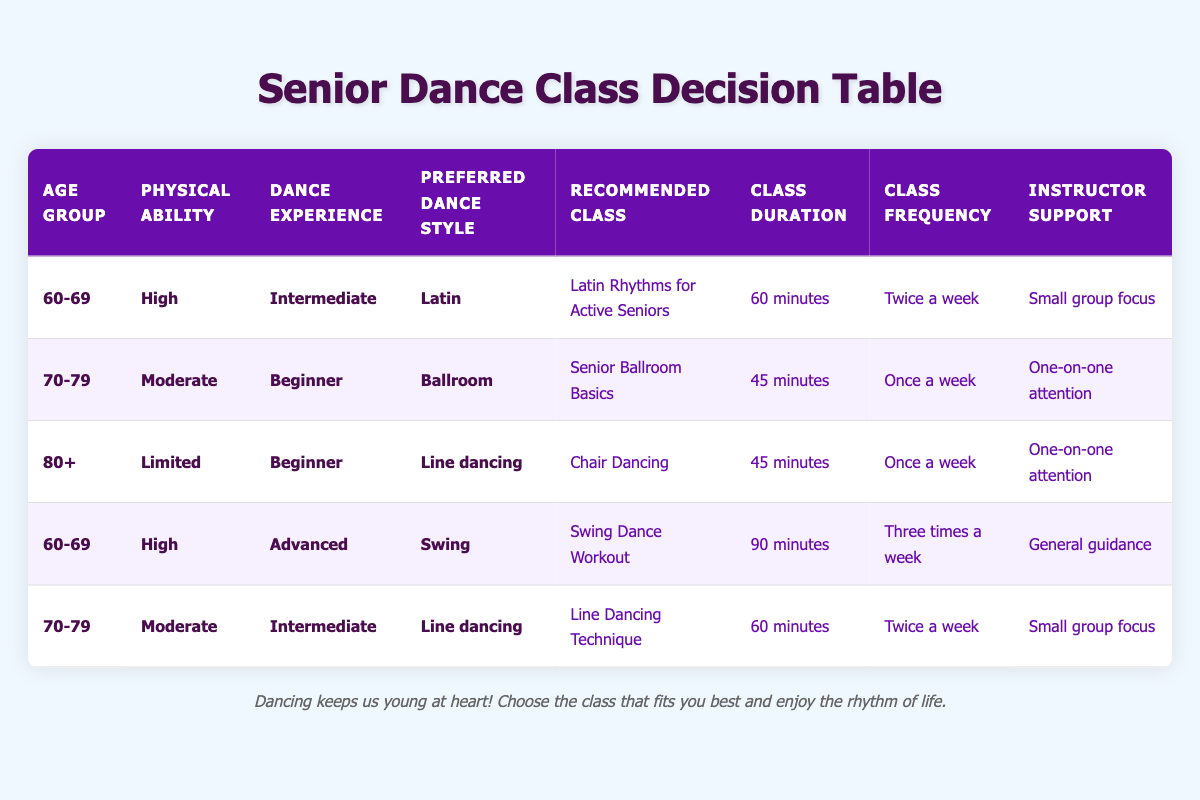What is the recommended class for an 80+ individual with limited physical ability and beginner dance experience in line dancing? The table indicates that for individuals aged 80+ with limited physical ability and beginner dance experience in line dancing, the recommended class is "Chair Dancing."
Answer: Chair Dancing How long is the class duration for "Swing Dance Workout"? The duration of "Swing Dance Workout" is specified in the table as 90 minutes.
Answer: 90 minutes Is "Senior Ballroom Basics" recommended for someone aged 70-79 with beginner dance experience? Yes, the table shows that "Senior Ballroom Basics" is indeed recommended for individuals aged 70-79 who are beginners.
Answer: Yes What class is recommended for someone aged 60-69 with high physical ability and advanced dance experience seeking a swing dance style? According to the table, the recommended class for this profile is "Swing Dance Workout."
Answer: Swing Dance Workout On how many occasions per week is "Line Dancing Technique" offered? The table specifies that "Line Dancing Technique" is offered twice a week.
Answer: Twice a week What is the average class duration for the classes recommended for individuals aged 70-79? To find the average duration: the classes for this age group are "Senior Ballroom Basics" (45 minutes), "Line Dancing Technique" (60 minutes). The sum is 45 + 60 = 105 minutes, and there are 2 classes. Therefore, the average is 105 / 2 = 52.5 minutes.
Answer: 52.5 minutes Does any of the classes recommended for individuals aged 60-69 require one-on-one instructor support? No, the table indicates that for individuals aged 60-69, all classes provided (like "Latin Rhythms for Active Seniors" and "Swing Dance Workout") have either small group focus or general guidance as instructor support, not one-on-one attention.
Answer: No Which dance style is associated with the "Latin Rhythms for Active Seniors"? "Latin Rhythms for Active Seniors" is associated with the Latin dance style according to the table.
Answer: Latin If a participant prefers line dancing but has limited physical ability and is a beginner, what class should they choose? Based on the table, they should choose "Chair Dancing," which is specifically recommended for this profile.
Answer: Chair Dancing 